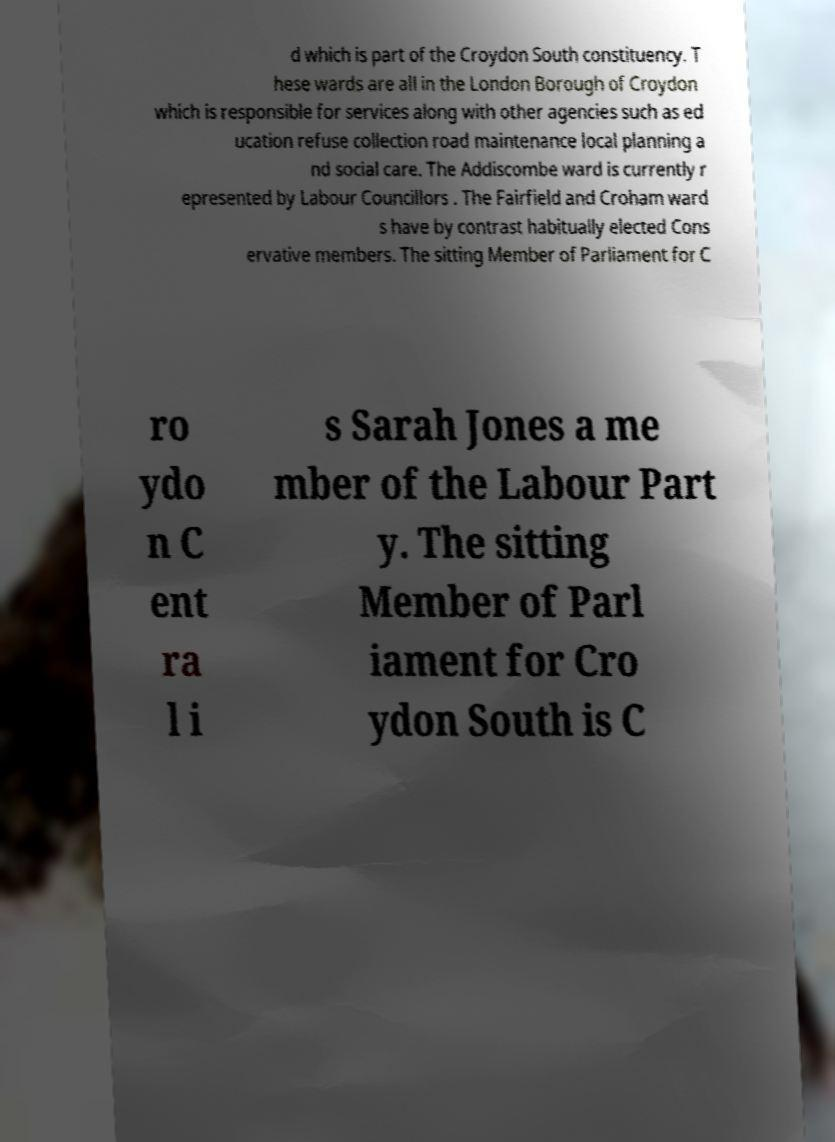What messages or text are displayed in this image? I need them in a readable, typed format. d which is part of the Croydon South constituency. T hese wards are all in the London Borough of Croydon which is responsible for services along with other agencies such as ed ucation refuse collection road maintenance local planning a nd social care. The Addiscombe ward is currently r epresented by Labour Councillors . The Fairfield and Croham ward s have by contrast habitually elected Cons ervative members. The sitting Member of Parliament for C ro ydo n C ent ra l i s Sarah Jones a me mber of the Labour Part y. The sitting Member of Parl iament for Cro ydon South is C 